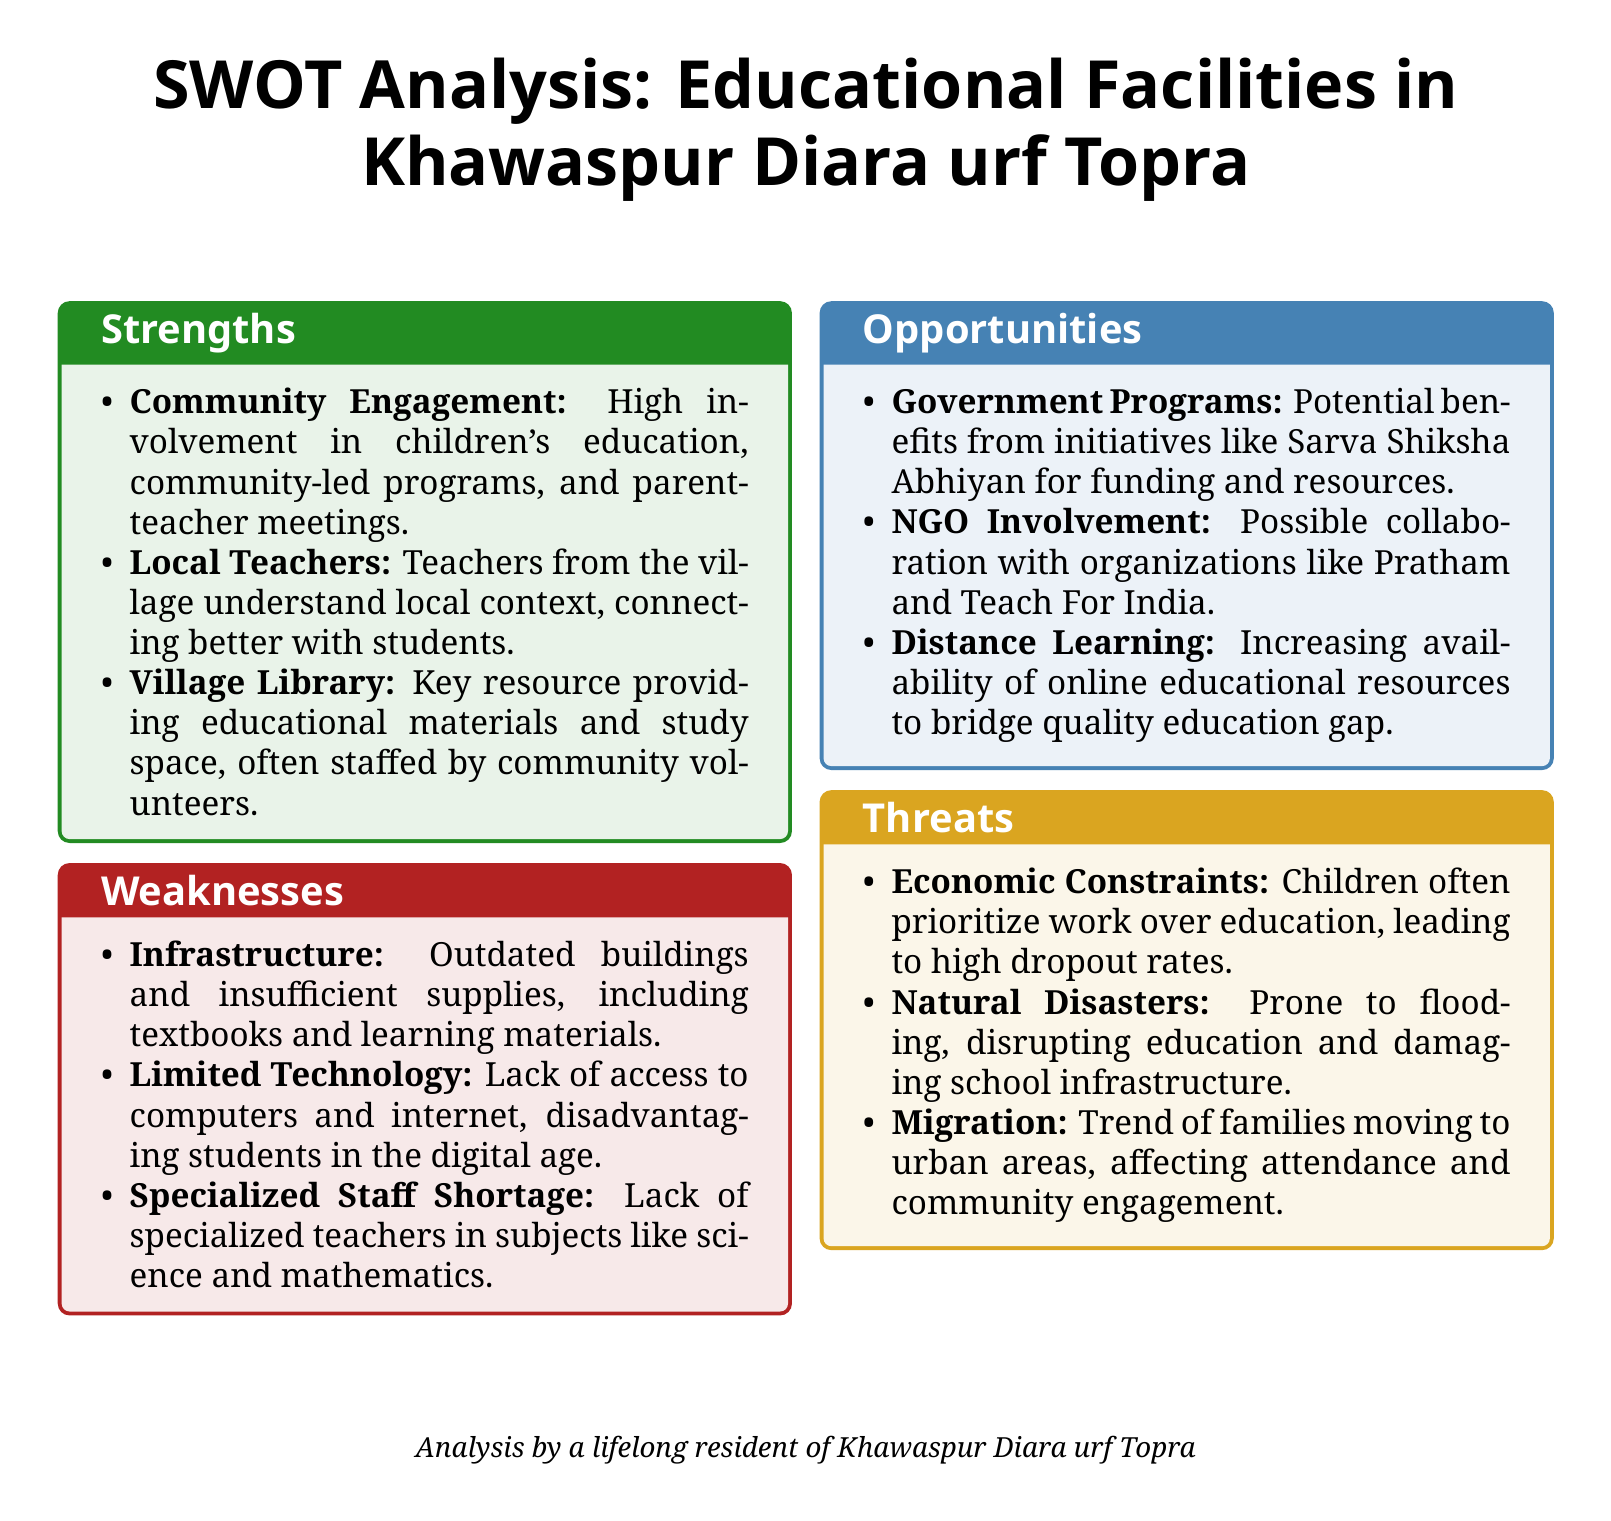What is the title of the document? The title is prominently displayed at the top of the document, summarizing its focus on educational facilities in a specific village.
Answer: SWOT Analysis: Educational Facilities in Khawaspur Diara urf Topra What is one strength related to community involvement? The document mentions high involvement in children's education, specifically through community-led programs.
Answer: Community Engagement What is one identified weakness concerning technology? The document states that there is a lack of access to important educational resources like computers and internet.
Answer: Limited Technology How many opportunities are listed in total? The opportunities section of the SWOT analysis includes three specific opportunities available for the educational facilities.
Answer: Three What is a threat related to economic factors? The document discusses how children often prioritize work over education, which impacts their school attendance negatively.
Answer: Economic Constraints What is one specialized subject that the document indicates has a shortage of teachers? The SWOT analysis notes a lack of specialty teachers specifically in science and mathematics.
Answer: Science and Mathematics Which government program is mentioned as a potential benefit for the village's educational facilities? The analysis highlights the Sarva Shiksha Abhiyan as a relevant government program that could support local education.
Answer: Sarva Shiksha Abhiyan What role does the village library play according to the strengths? The document describes the village library as a key resource that provides educational materials and study space.
Answer: Educational materials and study space What is the status of school infrastructure as noted in the weaknesses? The weaknesses section highlights that the school buildings are outdated and in need of improvement.
Answer: Outdated buildings 